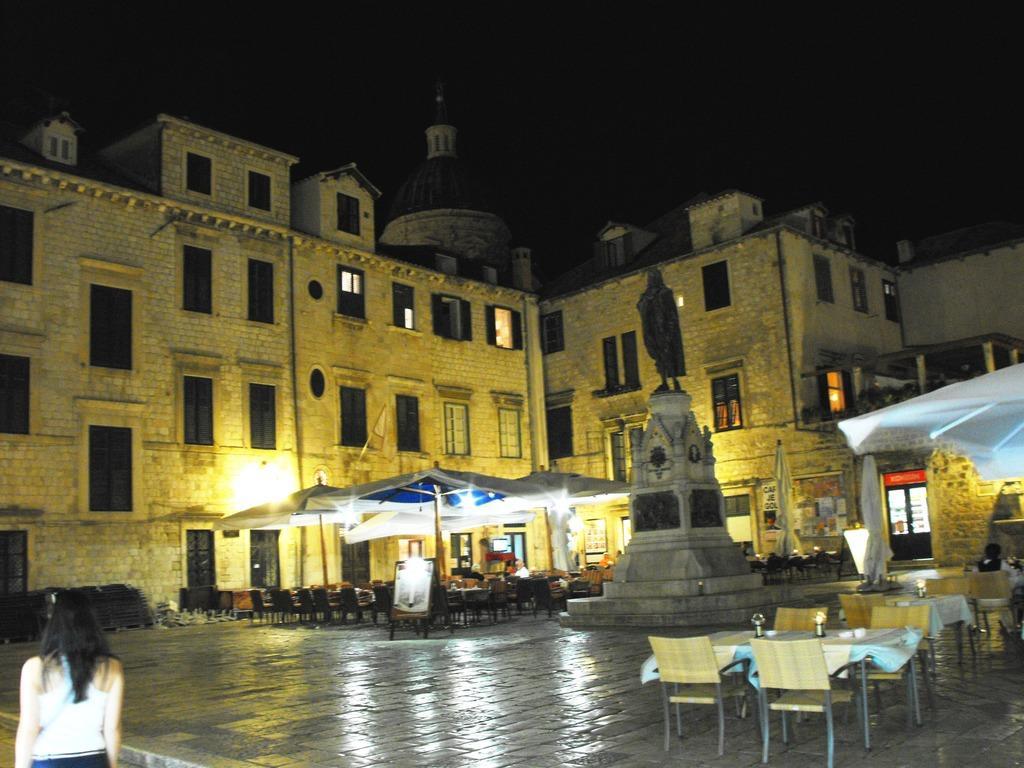Can you describe this image briefly? there is a building near to building there are many tables and chairs,there is a statue near to the building a woman is walking on the road. 